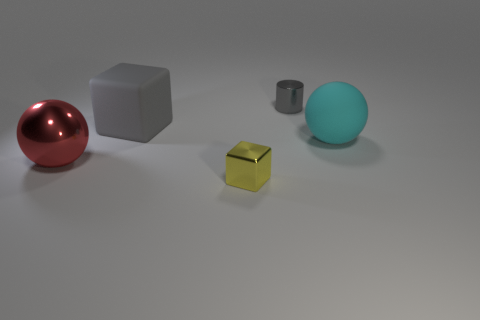What is the size of the yellow object that is made of the same material as the big red object?
Make the answer very short. Small. Is there any other thing that is the same color as the small shiny block?
Give a very brief answer. No. Is the material of the big gray thing the same as the tiny thing in front of the gray shiny cylinder?
Make the answer very short. No. There is a big cyan thing that is the same shape as the red shiny thing; what material is it?
Ensure brevity in your answer.  Rubber. Are the block that is in front of the gray cube and the gray thing that is in front of the small gray metallic object made of the same material?
Your answer should be compact. No. There is a large sphere that is on the left side of the gray thing in front of the small thing behind the big cyan matte ball; what is its color?
Make the answer very short. Red. How many other things are the same shape as the tiny gray shiny thing?
Keep it short and to the point. 0. Do the big metallic sphere and the tiny metallic cylinder have the same color?
Provide a short and direct response. No. How many things are tiny things or objects that are left of the metal cube?
Offer a terse response. 4. Are there any cubes that have the same size as the cyan matte thing?
Your response must be concise. Yes. 